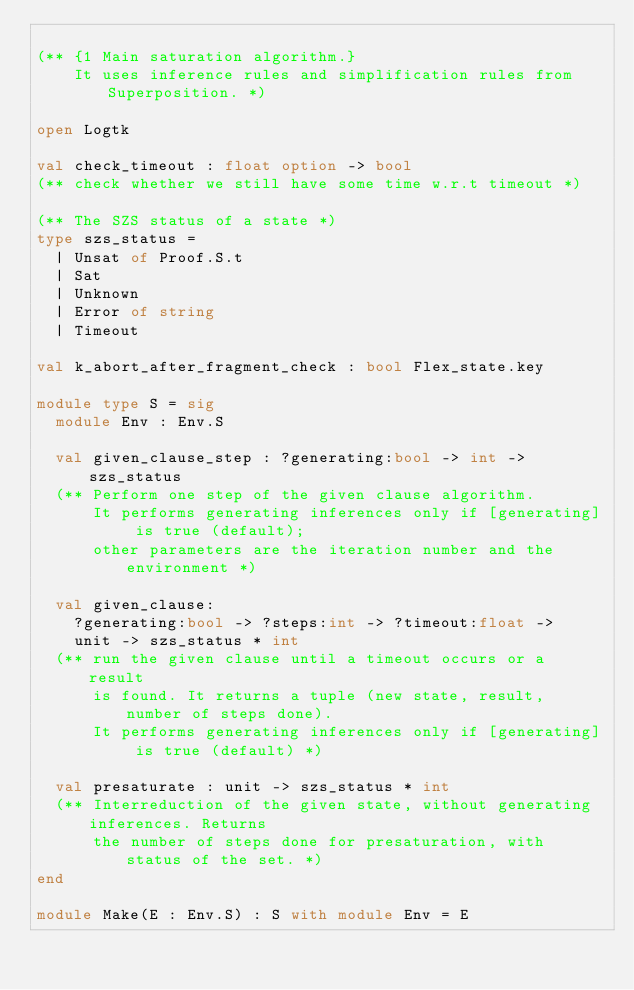Convert code to text. <code><loc_0><loc_0><loc_500><loc_500><_OCaml_>
(** {1 Main saturation algorithm.}
    It uses inference rules and simplification rules from Superposition. *)

open Logtk

val check_timeout : float option -> bool
(** check whether we still have some time w.r.t timeout *)

(** The SZS status of a state *)
type szs_status =
  | Unsat of Proof.S.t
  | Sat
  | Unknown
  | Error of string
  | Timeout

val k_abort_after_fragment_check : bool Flex_state.key

module type S = sig
  module Env : Env.S

  val given_clause_step : ?generating:bool -> int -> szs_status
  (** Perform one step of the given clause algorithm.
      It performs generating inferences only if [generating] is true (default);
      other parameters are the iteration number and the environment *)

  val given_clause:
    ?generating:bool -> ?steps:int -> ?timeout:float ->
    unit -> szs_status * int
  (** run the given clause until a timeout occurs or a result
      is found. It returns a tuple (new state, result, number of steps done).
      It performs generating inferences only if [generating] is true (default) *)

  val presaturate : unit -> szs_status * int
  (** Interreduction of the given state, without generating inferences. Returns
      the number of steps done for presaturation, with status of the set. *)
end

module Make(E : Env.S) : S with module Env = E
</code> 